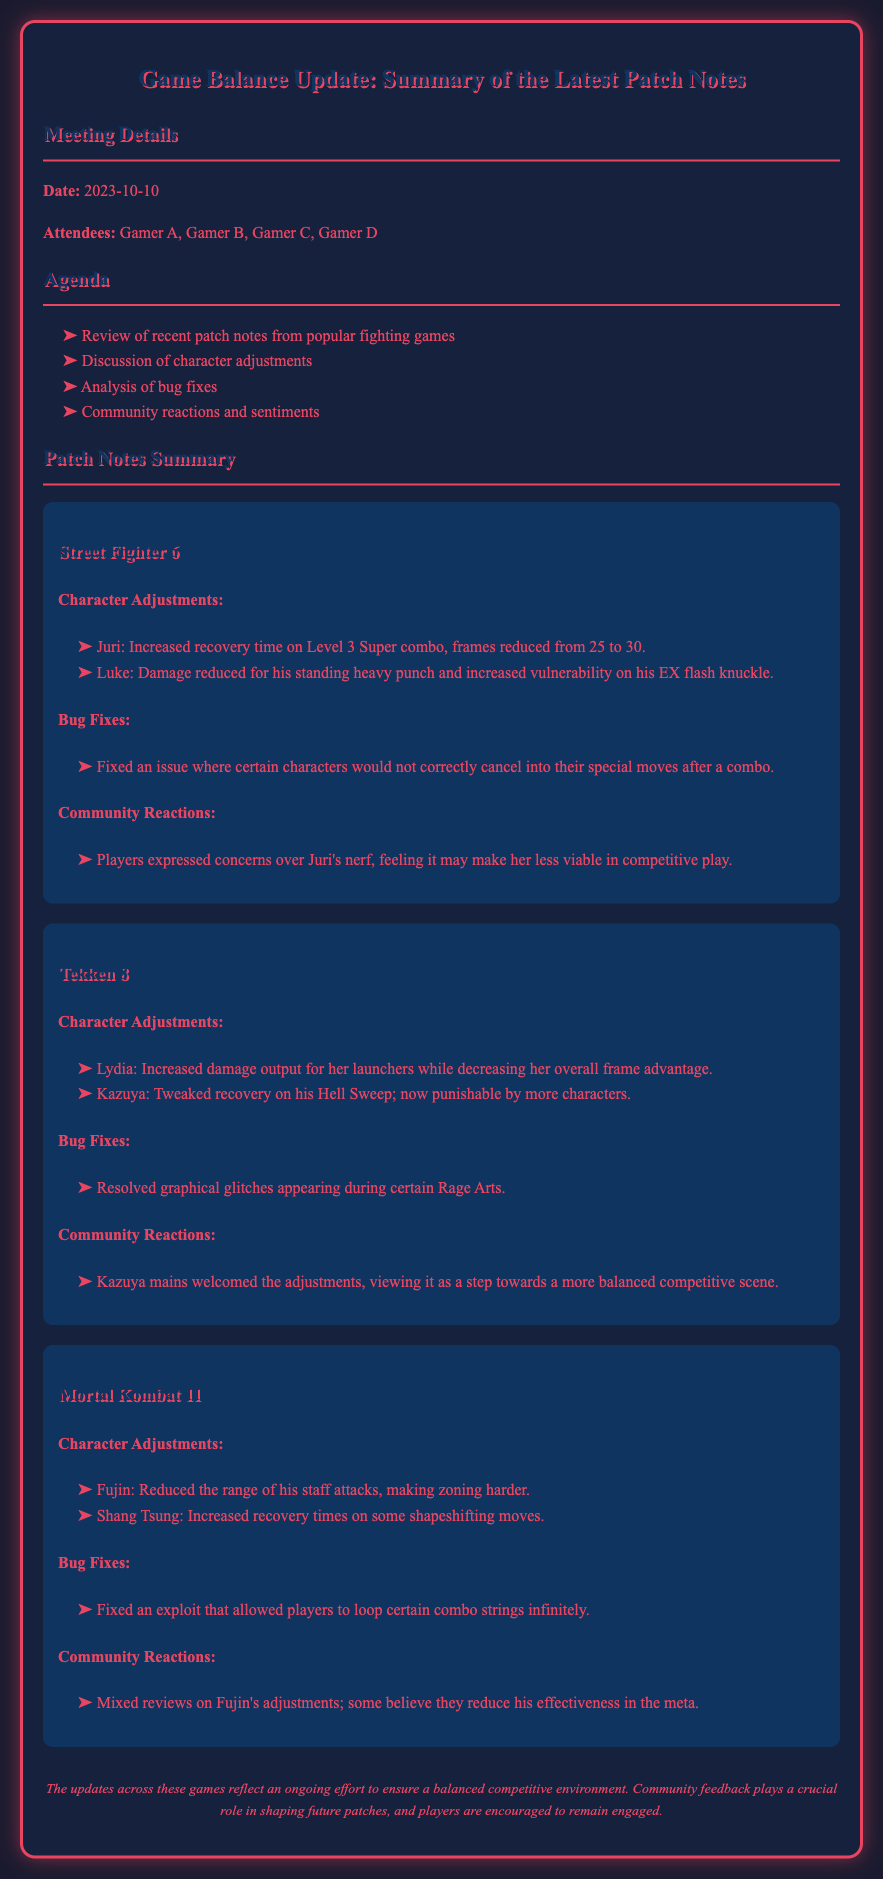What is the date of the meeting? The date of the meeting is explicitly stated in the document.
Answer: 2023-10-10 Who expressed concerns over Juri's nerf? The document mentions that players expressed concerns, specifying the group rather than an individual.
Answer: Players What character had decreased recovery time on his Hell Sweep? This character's name is mentioned in the "Character Adjustments" section for Tekken 8.
Answer: Kazuya How many attendees were present at the meeting? The document lists the attendees at the beginning, counting them directly.
Answer: 4 What was resolved in Tekken 8's bug fixes? The specific issue fixed in the bug fixes section is listed clearly.
Answer: Graphical glitches What is noted about community reactions to Fujin's adjustments? The document summarizes community sentiments about the adjustments made to Fujin.
Answer: Mixed reviews What specific adjustment was made to Shang Tsung's moves? The adjustment regarding Shang Tsung's moves is mentioned in the "Character Adjustments."
Answer: Increased recovery times Which game had a fixed exploit that allowed infinite combo looping? The exploit fix is referenced in the "Bug Fixes" section of a specific game.
Answer: Mortal Kombat 11 